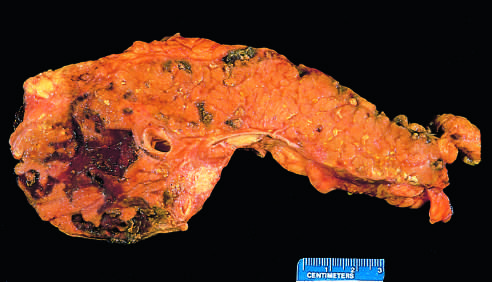what has been sectioned longitudinally to reveal dark areas of hemorrhage in the pancreatic substance and a focal area of pale fat necrosis in the peripancreatic fat upper left?
Answer the question using a single word or phrase. The pancreas 